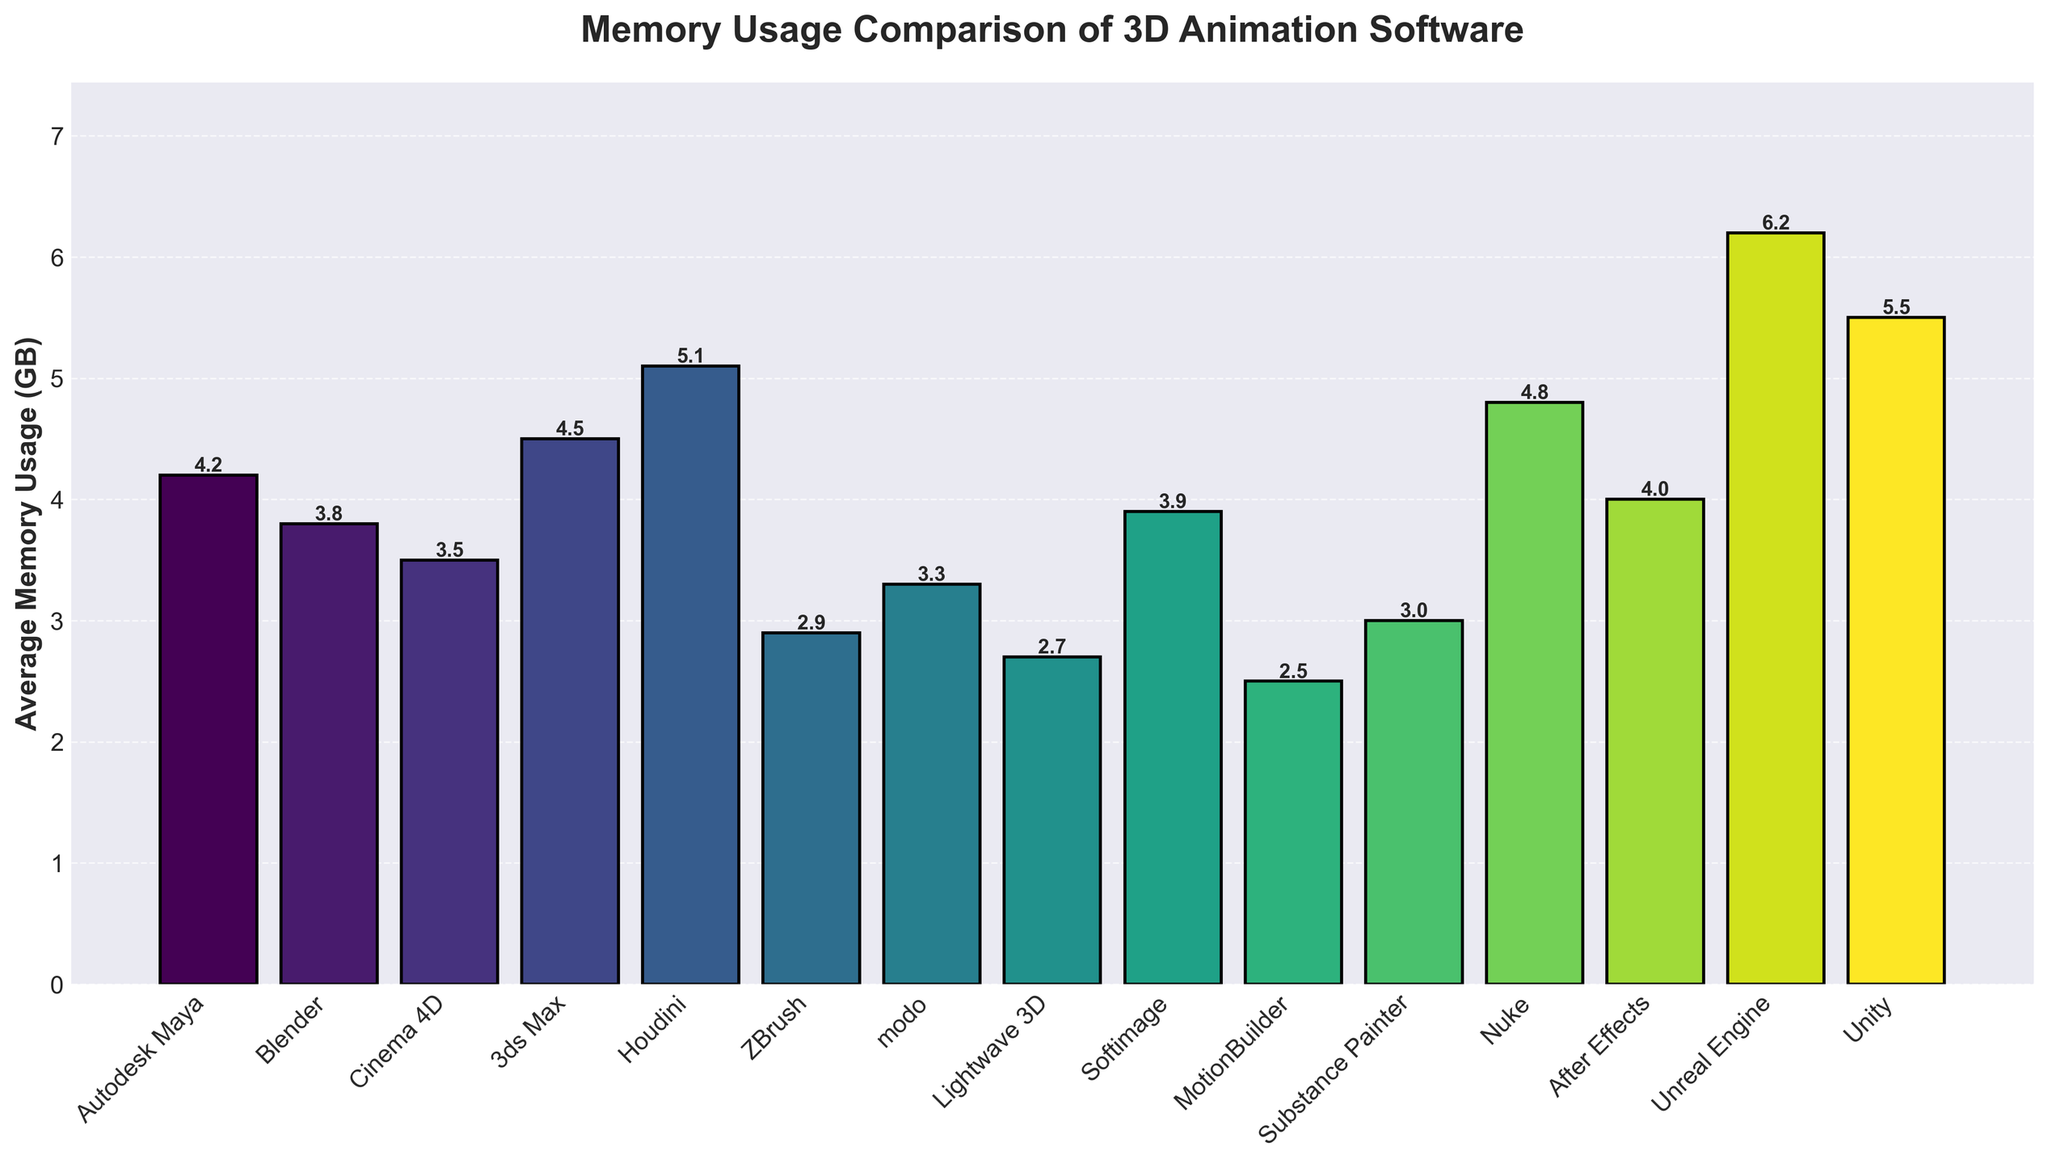Which software uses the most memory? By examining the height of the bars in the chart, Unreal Engine has the highest bar, indicating it uses the most memory.
Answer: Unreal Engine Which software has the lowest memory usage? The shortest bar on the chart corresponds to MotionBuilder, which indicates it has the lowest memory usage.
Answer: MotionBuilder How much more memory does Houdini use compared to Blender? Houdini uses 5.1 GB of memory, and Blender uses 3.8 GB. The difference is 5.1 - 3.8 = 1.3 GB.
Answer: 1.3 GB Is Cinema 4D's memory usage greater than that of ZBrush? Yes, the bar for Cinema 4D is taller than the bar for ZBrush. Cinema 4D uses 3.5 GB of memory, whereas ZBrush uses 2.9 GB.
Answer: Yes Which software has a memory usage closest to the median value of all displayed software? Listing the memory usages (2.5, 2.7, 2.9, 3.0, 3.3, 3.5, 3.8, 3.9, 4.0, 4.2, 4.5, 4.8, 5.1, 5.5, 6.2) and finding the median (middle value when sorted), we see that 3.9 is the median. Softimage has a memory usage of 3.9 GB.
Answer: Softimage Which has the closer memory usage to 4 GB: After Effects or Nuke? After Effects uses 4.0 GB and Nuke uses 4.8 GB. Since 4.0 is exactly 4 GB, After Effects is closer.
Answer: After Effects List the software that uses more than 5 GB of memory. By looking at the chart, the bars for Houdini (5.1 GB), Unity (5.5 GB), and Unreal Engine (6.2 GB) exceed the 5 GB mark.
Answer: Houdini, Unity, Unreal Engine What is the average memory usage of Autodesk Maya, Blender, and Cinema 4D combined? Their memory usages are 4.2 GB, 3.8 GB, and 3.5 GB respectively. The average is calculated as (4.2 + 3.8 + 3.5)/3 = 11.5/3 ≈ 3.83 GB.
Answer: 3.83 GB How much more memory, in total, does Unreal Engine use compared to Lightwave 3D and MotionBuilder combined? Unreal Engine uses 6.2 GB, Lightwave 3D uses 2.7 GB, and MotionBuilder uses 2.5 GB. Combined, Lightwave 3D and MotionBuilder use 2.7 + 2.5 = 5.2 GB. The difference is 6.2 - 5.2 = 1.0 GB.
Answer: 1.0 GB Are there more software options utilizing less than or equal to 4 GB of memory or more than 4 GB of memory? Devices using <= 4 GB: Blender, Cinema 4D, ZBrush, modo, Lightwave 3D, Softimage, MotionBuilder, Substance Painter, After Effects. Devices using > 4 GB: Autodesk Maya, 3ds Max, Houdini, Nuke, Unreal Engine, Unity. Thus, 9 options ≤ 4 GB and 6 options > 4 GB.
Answer: Less than or equal to 4 GB 